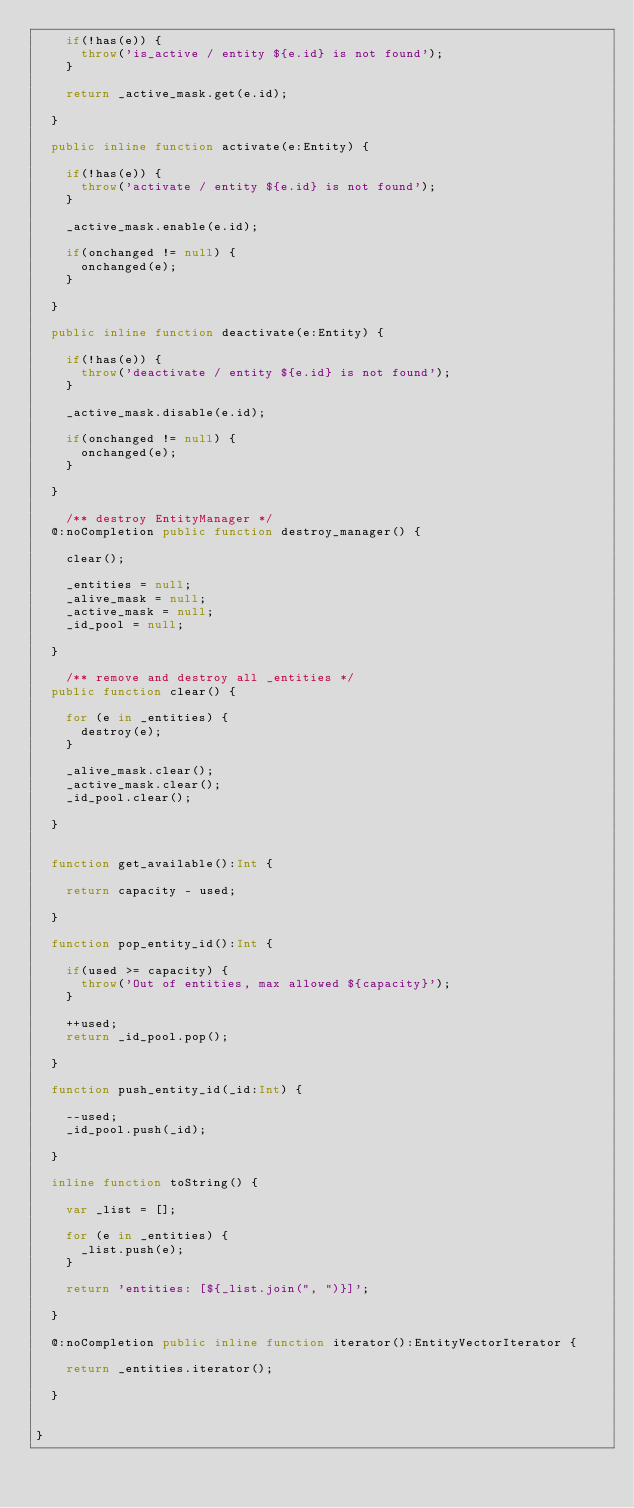Convert code to text. <code><loc_0><loc_0><loc_500><loc_500><_Haxe_>		if(!has(e)) {
			throw('is_active / entity ${e.id} is not found');
		}

		return _active_mask.get(e.id);
		
	}

	public inline function activate(e:Entity) {

		if(!has(e)) {
			throw('activate / entity ${e.id} is not found');
		}

		_active_mask.enable(e.id);

		if(onchanged != null) {
			onchanged(e);
		}

	}

	public inline function deactivate(e:Entity) {

		if(!has(e)) {
			throw('deactivate / entity ${e.id} is not found');
		}

		_active_mask.disable(e.id);

		if(onchanged != null) {
			onchanged(e);
		}

	}

		/** destroy EntityManager */
	@:noCompletion public function destroy_manager() {

		clear();

		_entities = null;
		_alive_mask = null;
		_active_mask = null;
		_id_pool = null;
		
	}

		/** remove and destroy all _entities */
	public function clear() {

		for (e in _entities) {
			destroy(e);
		}

		_alive_mask.clear();
		_active_mask.clear();
		_id_pool.clear();

	}


	function get_available():Int {

		return capacity - used;

	}

	function pop_entity_id():Int {

		if(used >= capacity) {
			throw('Out of entities, max allowed ${capacity}');
		}

		++used;
		return _id_pool.pop();

	}

	function push_entity_id(_id:Int) {

		--used;
		_id_pool.push(_id);

	}

	inline function toString() {

		var _list = []; 

		for (e in _entities) {
			_list.push(e);
		}

		return 'entities: [${_list.join(", ")}]';

	}

	@:noCompletion public inline function iterator():EntityVectorIterator {

		return _entities.iterator();

	}


}</code> 